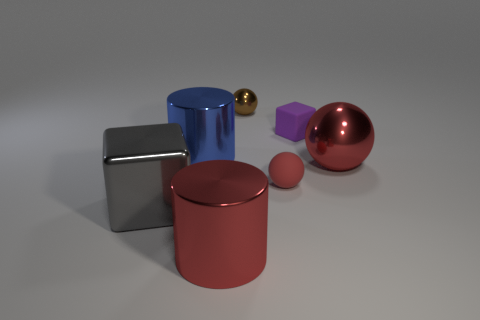Are the large red cylinder and the small purple cube made of the same material?
Offer a terse response. No. There is a large metal thing that is to the right of the red cylinder; what number of big cylinders are in front of it?
Ensure brevity in your answer.  1. Does the object that is to the right of the purple matte block have the same color as the large cube?
Your response must be concise. No. How many things are either big blue cylinders or tiny metallic things that are behind the tiny purple rubber cube?
Your answer should be compact. 2. Is the shape of the large shiny object that is right of the brown thing the same as the matte thing in front of the big blue object?
Your answer should be compact. Yes. Is there anything else that is the same color as the tiny matte block?
Offer a terse response. No. What is the shape of the tiny brown object that is made of the same material as the gray object?
Offer a terse response. Sphere. What is the material of the thing that is in front of the purple block and on the right side of the red matte sphere?
Provide a short and direct response. Metal. Is the matte cube the same color as the big block?
Provide a short and direct response. No. The shiny thing that is the same color as the large metallic sphere is what shape?
Your response must be concise. Cylinder. 